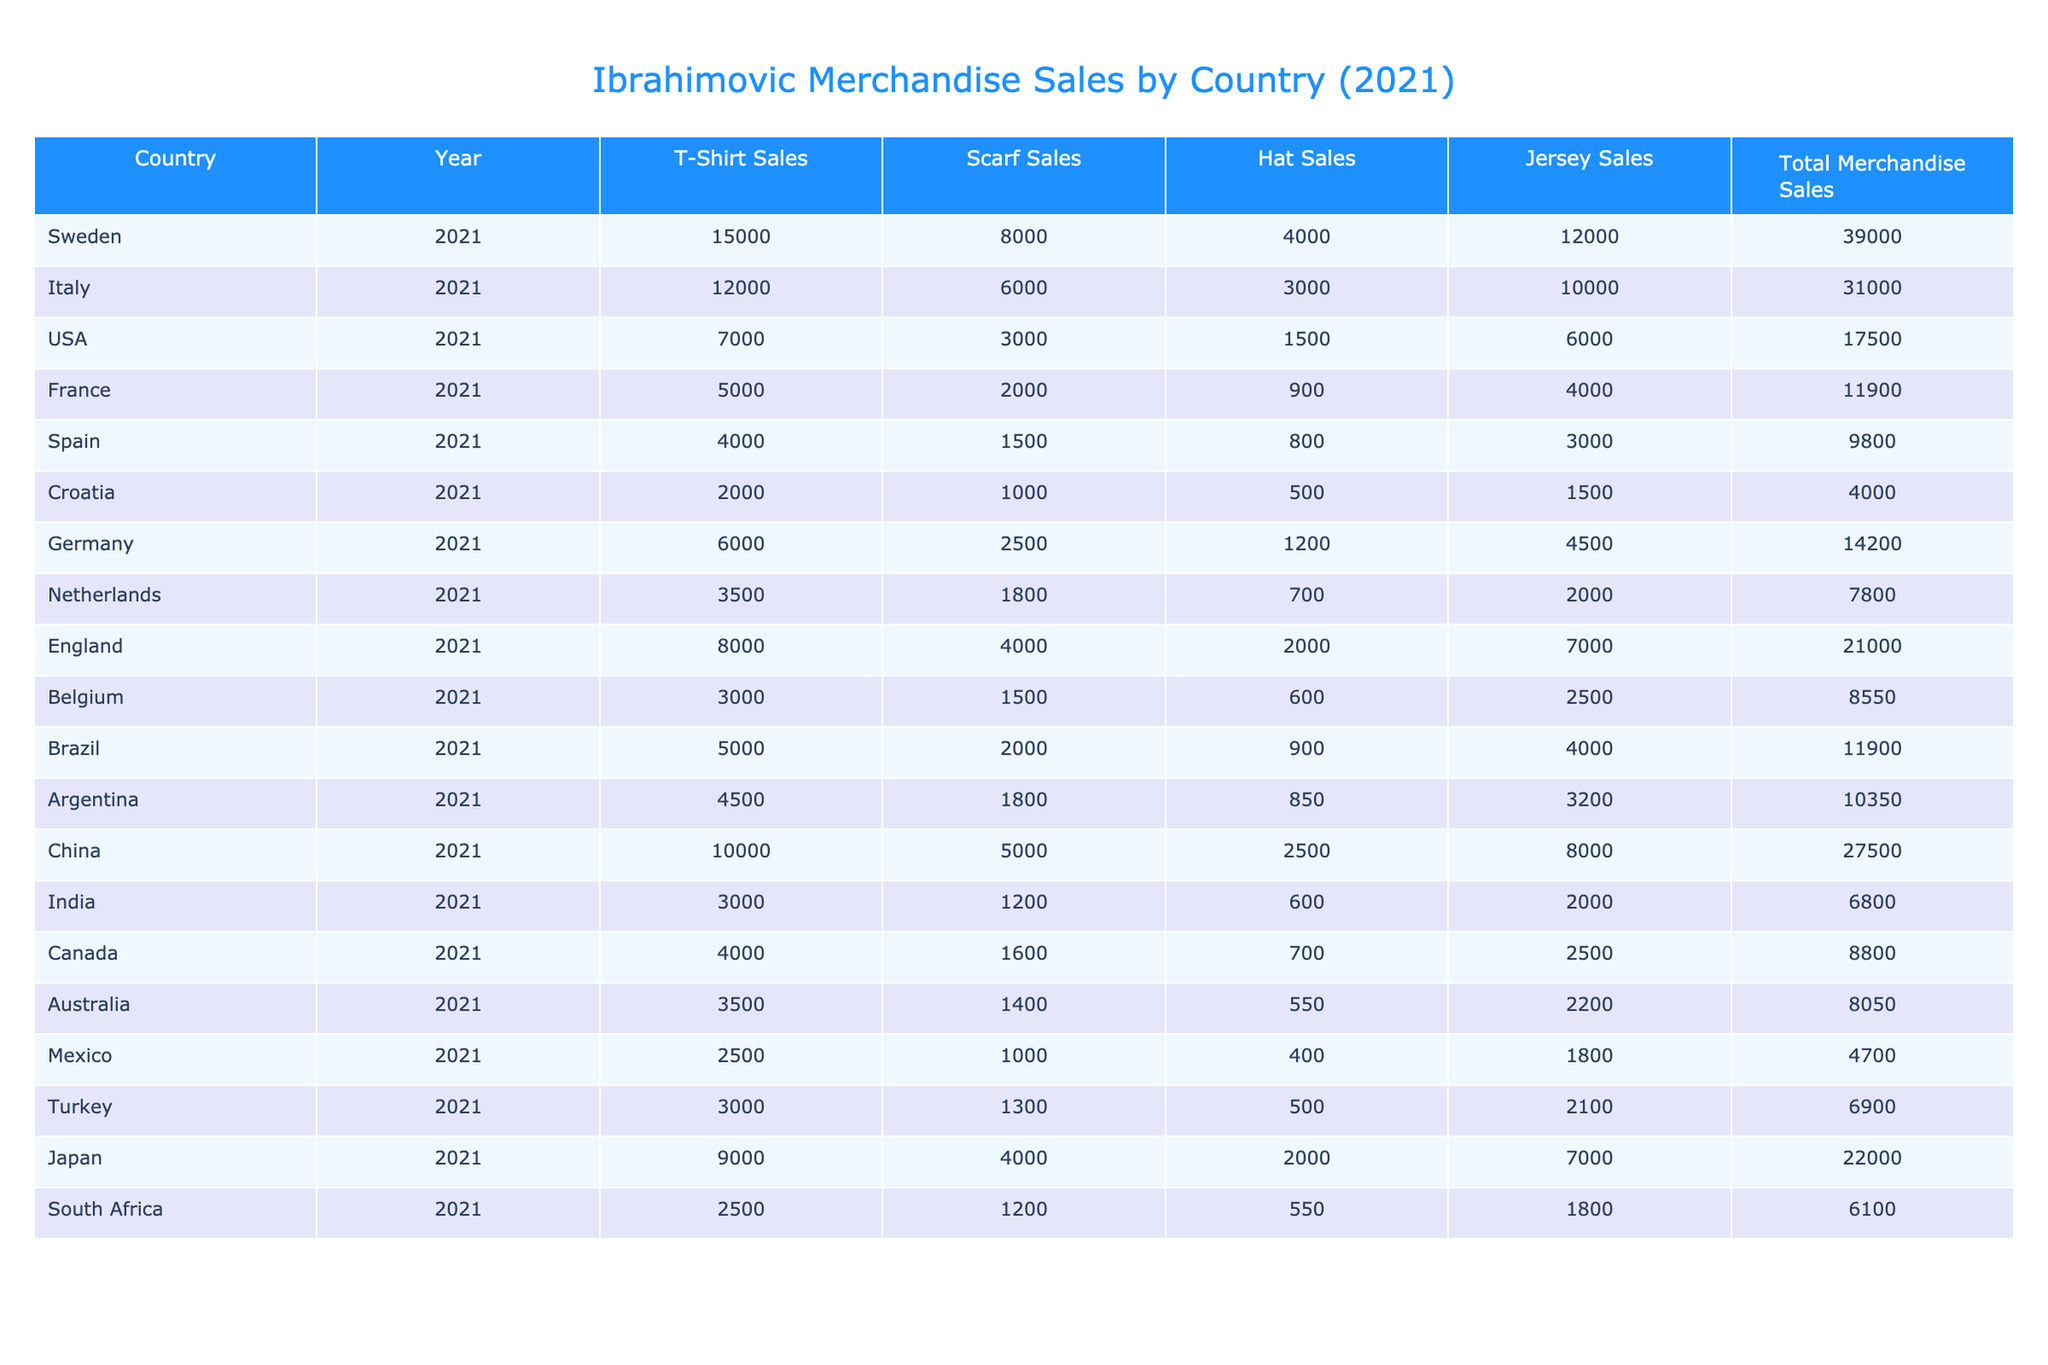What country had the highest total merchandise sales? By comparing the "Total Merchandise Sales" values for each country, Sweden had the highest total at 39,000.
Answer: Sweden Which country sold the least jerseys? The jerseys sales figures show that Croatia had the least with 1,500 jerseys sold.
Answer: Croatia How many total merchandise sales were made in Italy? The table shows that Italy had a total merchandise sales amount of 31,000.
Answer: 31,000 What is the average T-shirt sales from the countries listed? To find the average, sum the T-shirt sales (15,000 + 12,000 + 7,000 + 5,000 + 4,000 + 2,000 + 6,000 + 3,500 + 8,000 + 3,000 + 5,000 + 4,500 + 10,000 + 3,000 + 4,000 + 3,500 + 2,500 + 3,000 + 9,000 + 2,500) which equals 104,500, and divide by the number of countries (20), resulting in an average of 5,225.
Answer: 5,225 Did any country sell more scarves than the total jersey sales? By examining scarf sales (for example, Sweden with 8,000 and the jersey sales of 12,000), none of the countries have scarf sales exceeding their jersey sales total, as all values are lower.
Answer: No Which country had T-shirt sales that exceed 8,000 units? Observing the T-shirt sales column, Sweden (15,000), Italy (12,000), China (10,000), and Japan (9,000) all exceeded 8,000.
Answer: Sweden, Italy, China, Japan What were the total jersey sales across all countries? By adding the jersey sales (12,000 + 10,000 + 6,000 + 4,000 + 3,000 + 1,500 + 4,500 + 2,000 + 7,000 + 3,200 + 8,000 + 2,500 + 7,000 + 2,100 + 2,200 + 1,800) yields a total of 46,300.
Answer: 46,300 Which country had the highest hat sales? The hat sales figures show that China had the highest at 2,500 hats sold.
Answer: China What was the total sales in the USA compared to India? The USA had total sales of 17,500, while India had 6,800. This reveals that the USA's total sales significantly exceeded India's.
Answer: USA had higher sales Were more scarves sold in Brazil than in Argentina? Brazil sold 2,000 scarves while Argentina sold 1,800, confirming that Brazil had more scarf sales.
Answer: Yes What is the difference in total merchandise sales between Sweden and Spain? The difference can be calculated by subtracting Spain's total (9,800) from Sweden's total (39,000), resulting in a difference of 29,200.
Answer: 29,200 